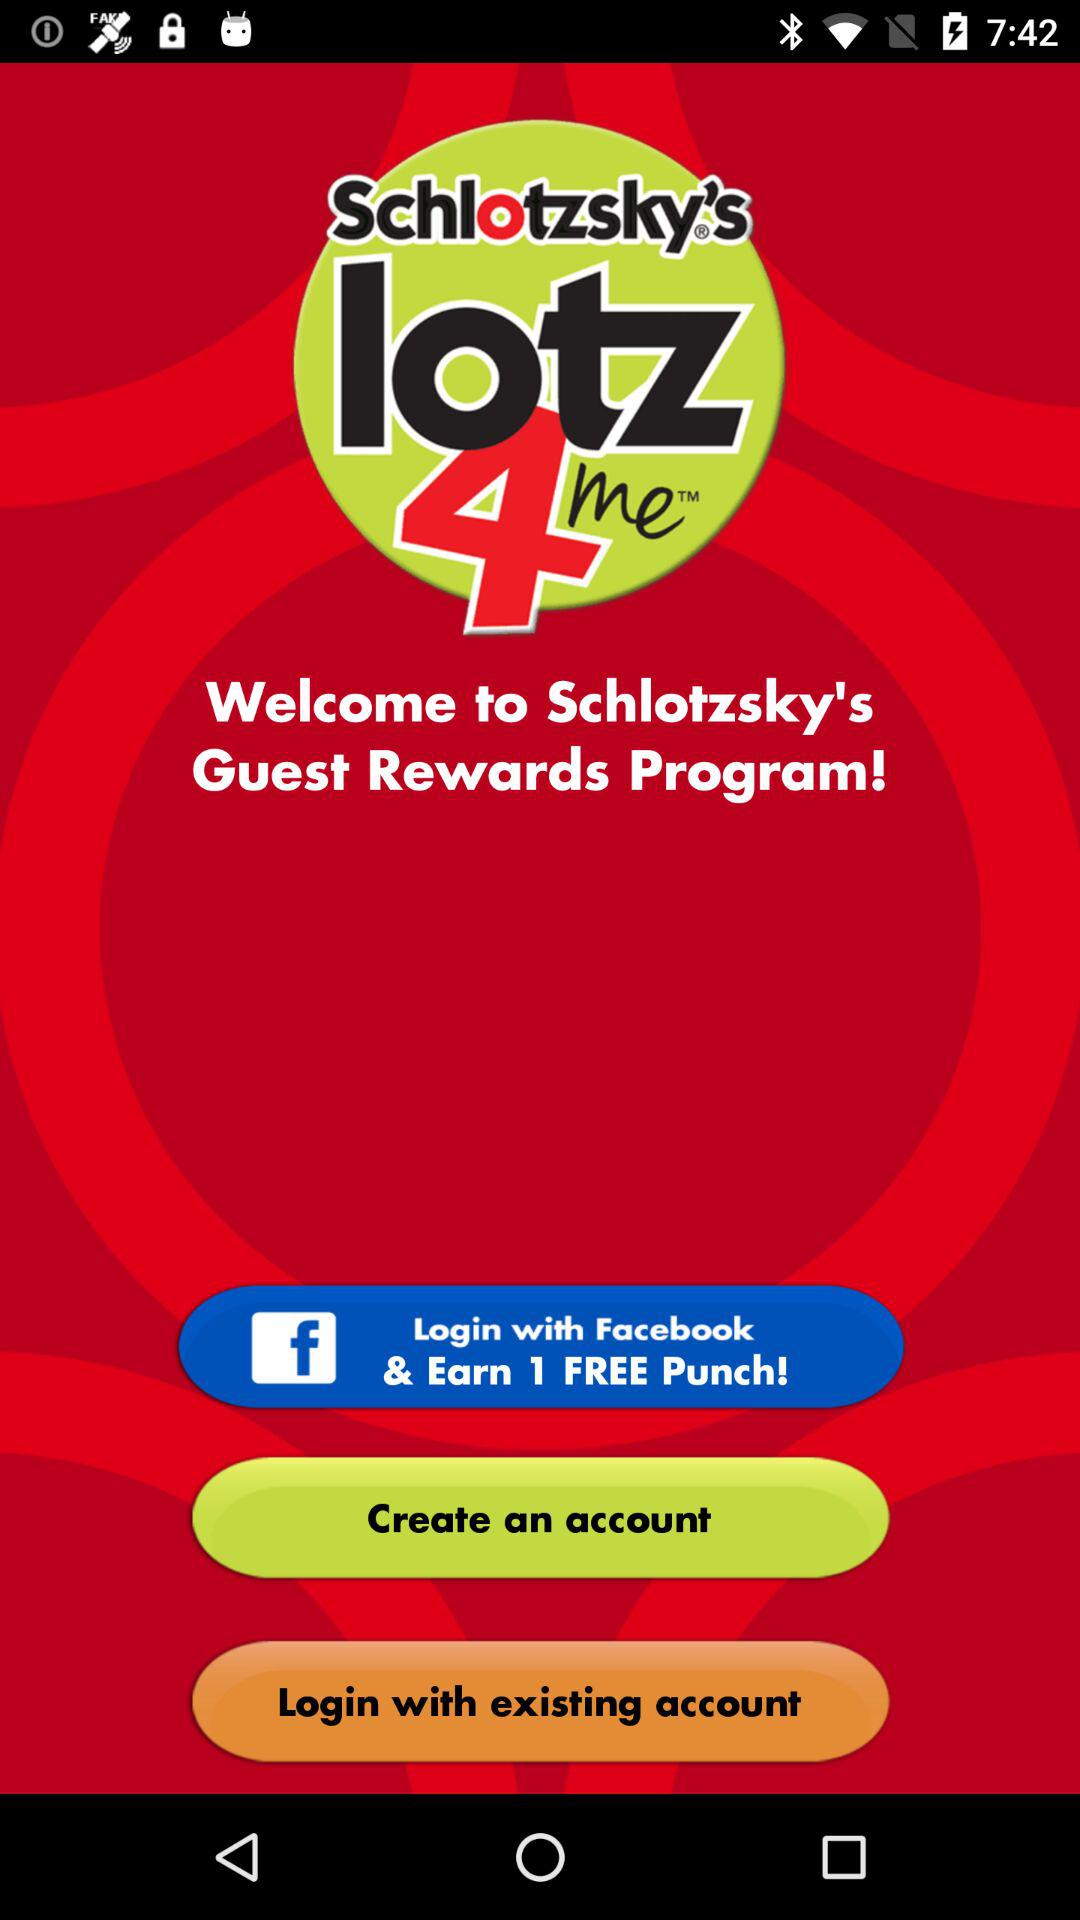What account can I use for logging in? You can use "Facebook" account for logging in. 